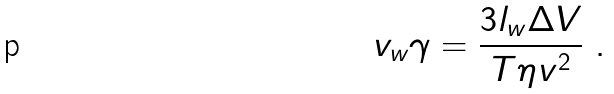Convert formula to latex. <formula><loc_0><loc_0><loc_500><loc_500>v _ { w } \gamma = \frac { 3 l _ { w } \Delta V } { T \eta v ^ { 2 } } \ .</formula> 